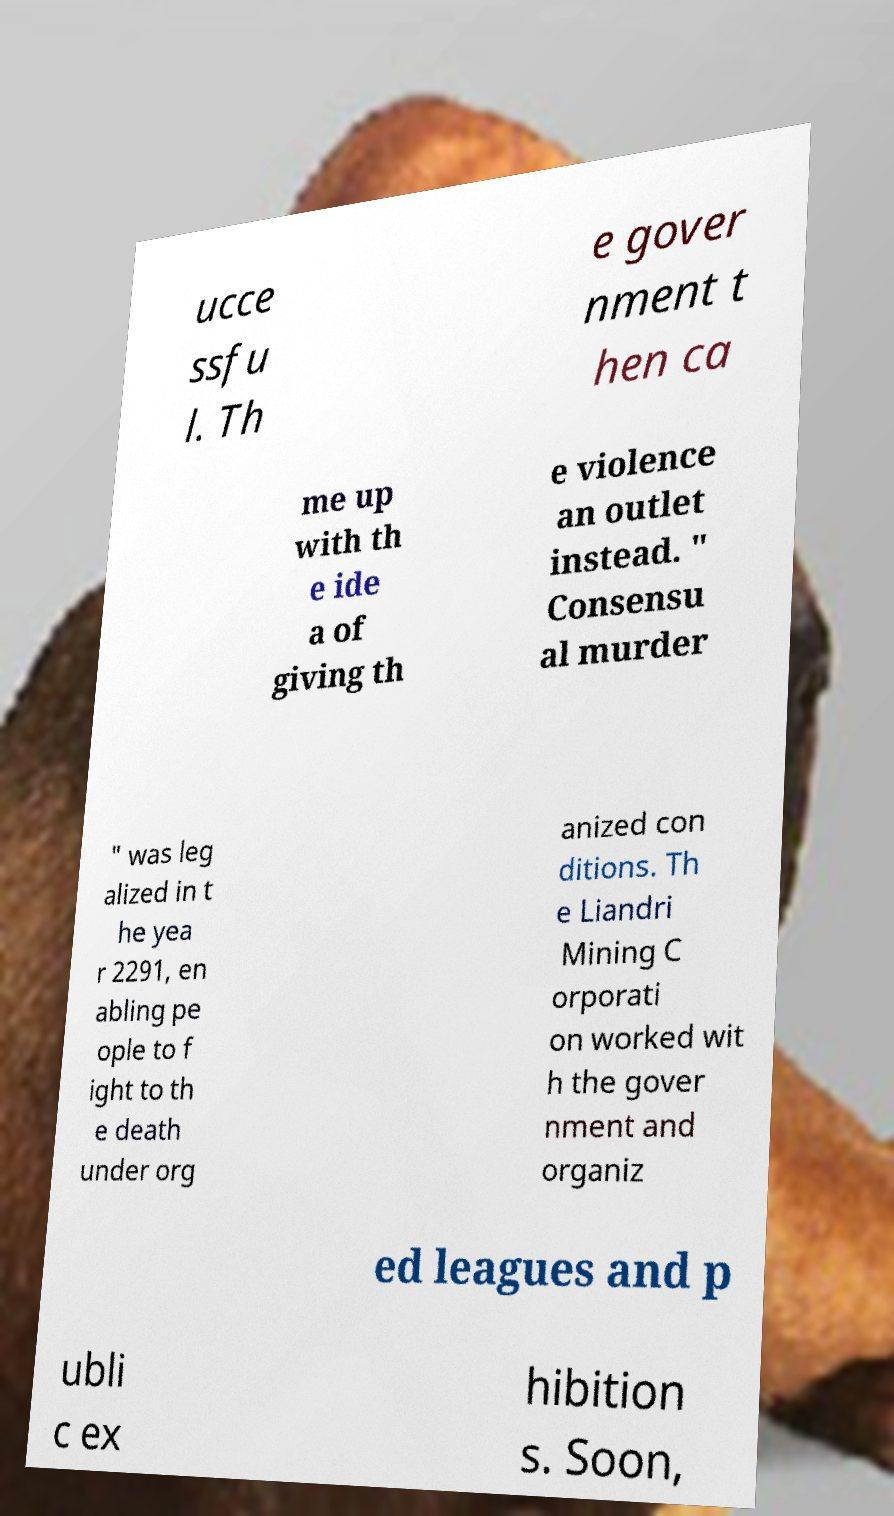What messages or text are displayed in this image? I need them in a readable, typed format. ucce ssfu l. Th e gover nment t hen ca me up with th e ide a of giving th e violence an outlet instead. " Consensu al murder " was leg alized in t he yea r 2291, en abling pe ople to f ight to th e death under org anized con ditions. Th e Liandri Mining C orporati on worked wit h the gover nment and organiz ed leagues and p ubli c ex hibition s. Soon, 